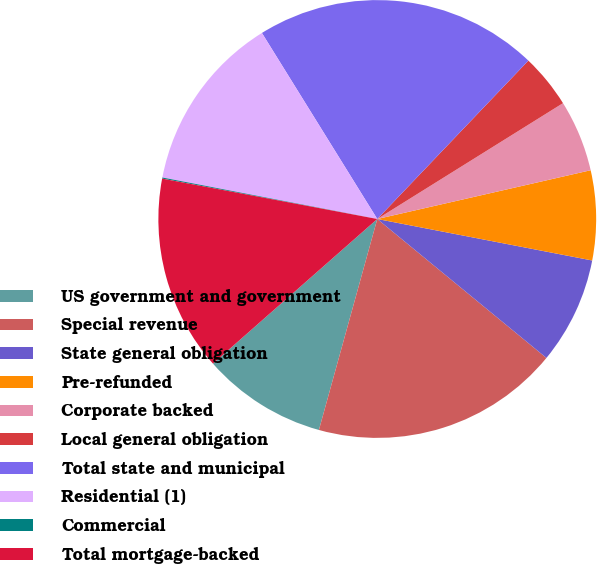Convert chart to OTSL. <chart><loc_0><loc_0><loc_500><loc_500><pie_chart><fcel>US government and government<fcel>Special revenue<fcel>State general obligation<fcel>Pre-refunded<fcel>Corporate backed<fcel>Local general obligation<fcel>Total state and municipal<fcel>Residential (1)<fcel>Commercial<fcel>Total mortgage-backed<nl><fcel>9.22%<fcel>18.35%<fcel>7.91%<fcel>6.61%<fcel>5.3%<fcel>4.0%<fcel>20.96%<fcel>13.13%<fcel>0.08%<fcel>14.44%<nl></chart> 